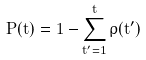Convert formula to latex. <formula><loc_0><loc_0><loc_500><loc_500>P ( t ) = 1 - \sum _ { t ^ { \prime } = 1 } ^ { t } \rho ( t ^ { \prime } )</formula> 